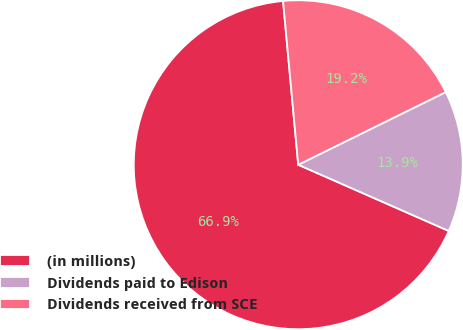<chart> <loc_0><loc_0><loc_500><loc_500><pie_chart><fcel>(in millions)<fcel>Dividends paid to Edison<fcel>Dividends received from SCE<nl><fcel>66.94%<fcel>13.88%<fcel>19.19%<nl></chart> 